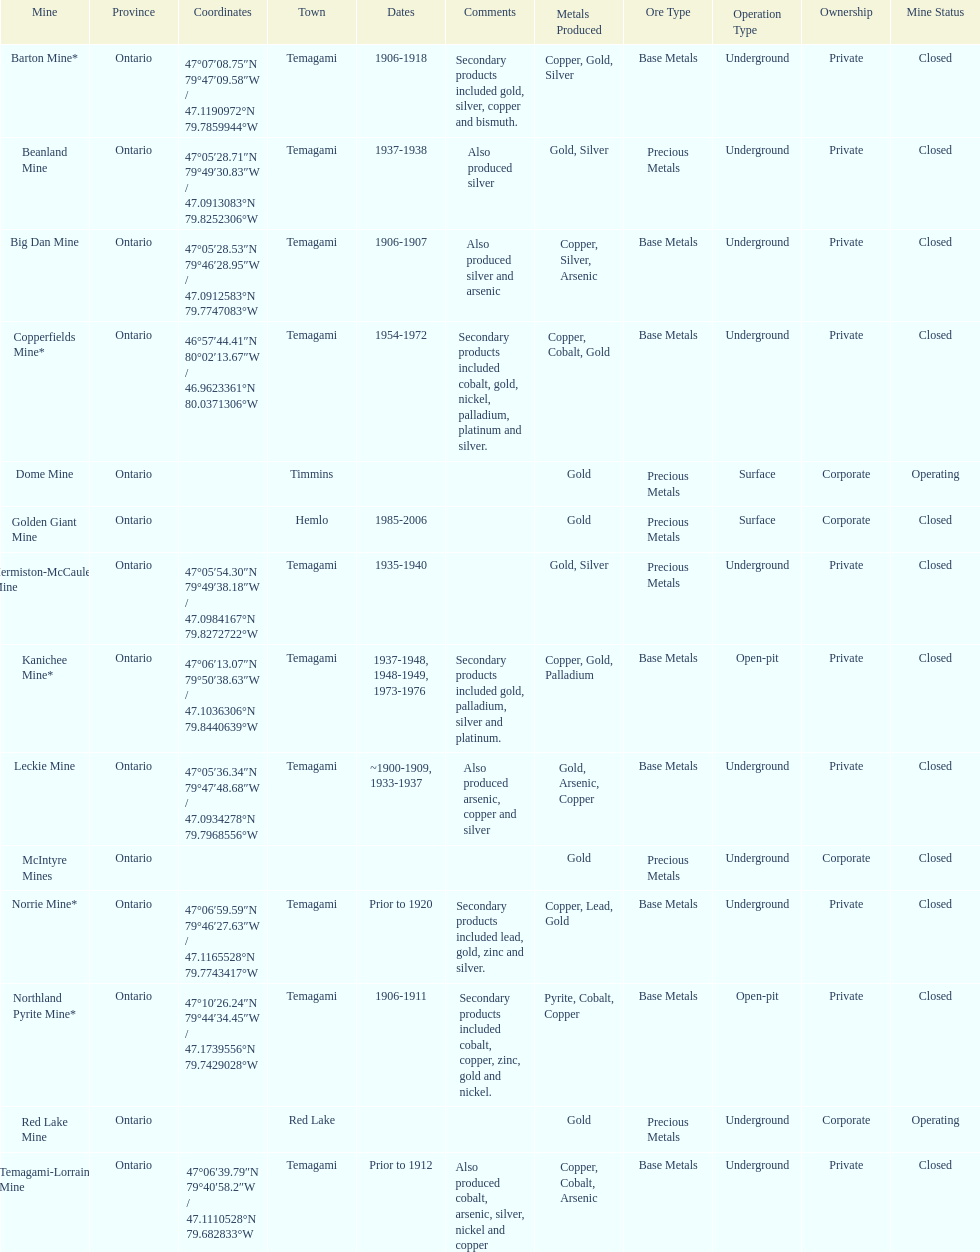How many mines were in temagami? 10. 